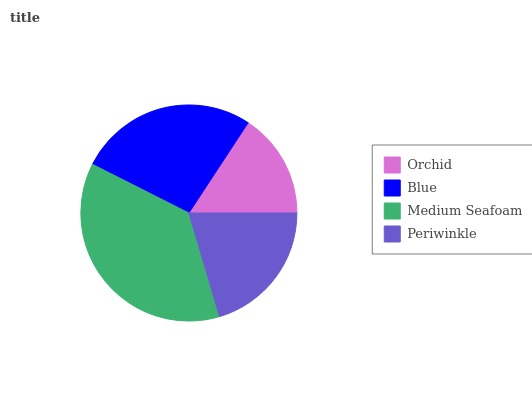Is Orchid the minimum?
Answer yes or no. Yes. Is Medium Seafoam the maximum?
Answer yes or no. Yes. Is Blue the minimum?
Answer yes or no. No. Is Blue the maximum?
Answer yes or no. No. Is Blue greater than Orchid?
Answer yes or no. Yes. Is Orchid less than Blue?
Answer yes or no. Yes. Is Orchid greater than Blue?
Answer yes or no. No. Is Blue less than Orchid?
Answer yes or no. No. Is Blue the high median?
Answer yes or no. Yes. Is Periwinkle the low median?
Answer yes or no. Yes. Is Medium Seafoam the high median?
Answer yes or no. No. Is Blue the low median?
Answer yes or no. No. 